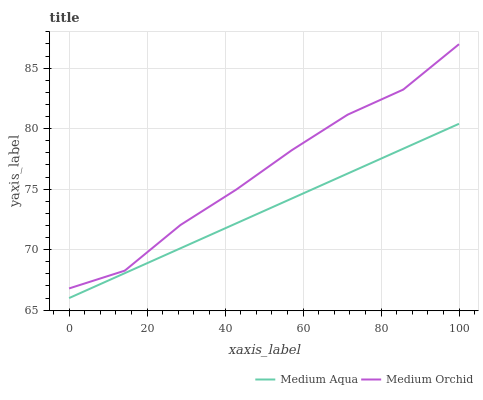Does Medium Aqua have the minimum area under the curve?
Answer yes or no. Yes. Does Medium Orchid have the maximum area under the curve?
Answer yes or no. Yes. Does Medium Aqua have the maximum area under the curve?
Answer yes or no. No. Is Medium Aqua the smoothest?
Answer yes or no. Yes. Is Medium Orchid the roughest?
Answer yes or no. Yes. Is Medium Aqua the roughest?
Answer yes or no. No. Does Medium Orchid have the highest value?
Answer yes or no. Yes. Does Medium Aqua have the highest value?
Answer yes or no. No. Is Medium Aqua less than Medium Orchid?
Answer yes or no. Yes. Is Medium Orchid greater than Medium Aqua?
Answer yes or no. Yes. Does Medium Aqua intersect Medium Orchid?
Answer yes or no. No. 